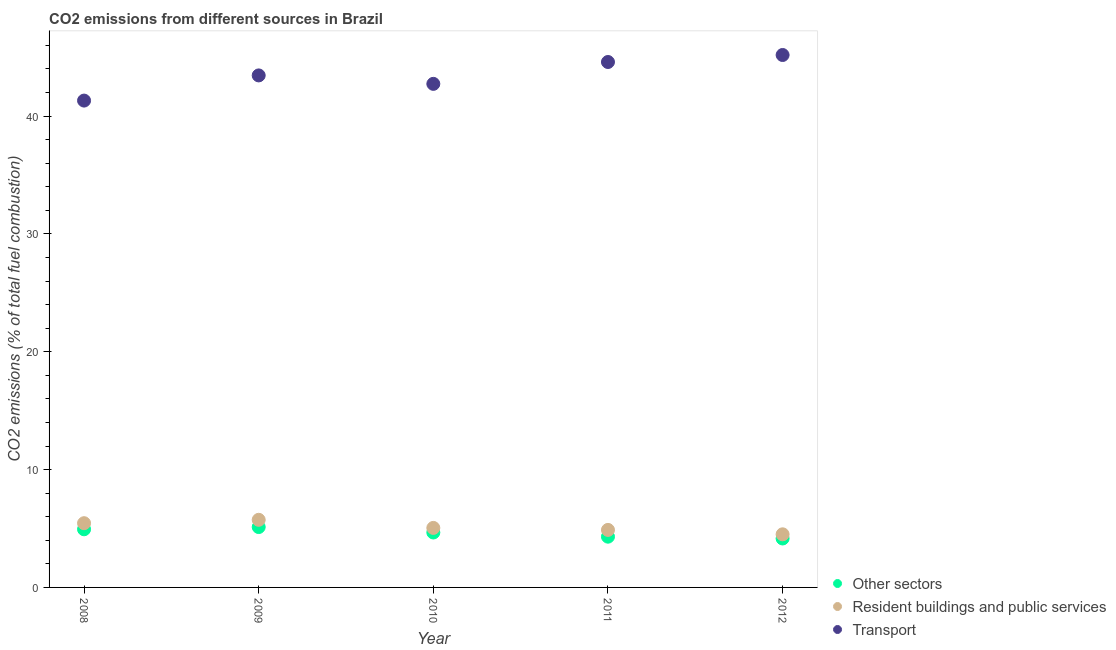How many different coloured dotlines are there?
Your response must be concise. 3. What is the percentage of co2 emissions from resident buildings and public services in 2010?
Offer a terse response. 5.05. Across all years, what is the maximum percentage of co2 emissions from other sectors?
Your answer should be very brief. 5.12. Across all years, what is the minimum percentage of co2 emissions from other sectors?
Offer a very short reply. 4.15. In which year was the percentage of co2 emissions from resident buildings and public services maximum?
Ensure brevity in your answer.  2009. What is the total percentage of co2 emissions from other sectors in the graph?
Provide a short and direct response. 23.18. What is the difference between the percentage of co2 emissions from other sectors in 2008 and that in 2009?
Offer a very short reply. -0.19. What is the difference between the percentage of co2 emissions from resident buildings and public services in 2011 and the percentage of co2 emissions from transport in 2010?
Provide a succinct answer. -37.85. What is the average percentage of co2 emissions from resident buildings and public services per year?
Provide a short and direct response. 5.12. In the year 2012, what is the difference between the percentage of co2 emissions from transport and percentage of co2 emissions from other sectors?
Your answer should be compact. 41.03. What is the ratio of the percentage of co2 emissions from resident buildings and public services in 2009 to that in 2012?
Your answer should be compact. 1.27. Is the percentage of co2 emissions from transport in 2010 less than that in 2012?
Make the answer very short. Yes. What is the difference between the highest and the second highest percentage of co2 emissions from transport?
Offer a very short reply. 0.59. What is the difference between the highest and the lowest percentage of co2 emissions from transport?
Keep it short and to the point. 3.87. Is the percentage of co2 emissions from other sectors strictly greater than the percentage of co2 emissions from transport over the years?
Give a very brief answer. No. What is the difference between two consecutive major ticks on the Y-axis?
Provide a short and direct response. 10. How many legend labels are there?
Your answer should be compact. 3. How are the legend labels stacked?
Make the answer very short. Vertical. What is the title of the graph?
Keep it short and to the point. CO2 emissions from different sources in Brazil. Does "Nuclear sources" appear as one of the legend labels in the graph?
Provide a short and direct response. No. What is the label or title of the X-axis?
Your answer should be compact. Year. What is the label or title of the Y-axis?
Offer a very short reply. CO2 emissions (% of total fuel combustion). What is the CO2 emissions (% of total fuel combustion) of Other sectors in 2008?
Your answer should be very brief. 4.93. What is the CO2 emissions (% of total fuel combustion) in Resident buildings and public services in 2008?
Your answer should be compact. 5.45. What is the CO2 emissions (% of total fuel combustion) in Transport in 2008?
Give a very brief answer. 41.31. What is the CO2 emissions (% of total fuel combustion) in Other sectors in 2009?
Ensure brevity in your answer.  5.12. What is the CO2 emissions (% of total fuel combustion) in Resident buildings and public services in 2009?
Your answer should be very brief. 5.74. What is the CO2 emissions (% of total fuel combustion) in Transport in 2009?
Provide a succinct answer. 43.45. What is the CO2 emissions (% of total fuel combustion) in Other sectors in 2010?
Ensure brevity in your answer.  4.66. What is the CO2 emissions (% of total fuel combustion) of Resident buildings and public services in 2010?
Your answer should be compact. 5.05. What is the CO2 emissions (% of total fuel combustion) of Transport in 2010?
Offer a terse response. 42.73. What is the CO2 emissions (% of total fuel combustion) in Other sectors in 2011?
Offer a very short reply. 4.31. What is the CO2 emissions (% of total fuel combustion) in Resident buildings and public services in 2011?
Your response must be concise. 4.88. What is the CO2 emissions (% of total fuel combustion) in Transport in 2011?
Ensure brevity in your answer.  44.58. What is the CO2 emissions (% of total fuel combustion) of Other sectors in 2012?
Ensure brevity in your answer.  4.15. What is the CO2 emissions (% of total fuel combustion) of Resident buildings and public services in 2012?
Provide a succinct answer. 4.51. What is the CO2 emissions (% of total fuel combustion) in Transport in 2012?
Ensure brevity in your answer.  45.18. Across all years, what is the maximum CO2 emissions (% of total fuel combustion) in Other sectors?
Provide a short and direct response. 5.12. Across all years, what is the maximum CO2 emissions (% of total fuel combustion) in Resident buildings and public services?
Ensure brevity in your answer.  5.74. Across all years, what is the maximum CO2 emissions (% of total fuel combustion) in Transport?
Provide a succinct answer. 45.18. Across all years, what is the minimum CO2 emissions (% of total fuel combustion) in Other sectors?
Provide a succinct answer. 4.15. Across all years, what is the minimum CO2 emissions (% of total fuel combustion) of Resident buildings and public services?
Offer a very short reply. 4.51. Across all years, what is the minimum CO2 emissions (% of total fuel combustion) in Transport?
Give a very brief answer. 41.31. What is the total CO2 emissions (% of total fuel combustion) of Other sectors in the graph?
Provide a succinct answer. 23.18. What is the total CO2 emissions (% of total fuel combustion) in Resident buildings and public services in the graph?
Keep it short and to the point. 25.62. What is the total CO2 emissions (% of total fuel combustion) of Transport in the graph?
Your answer should be very brief. 217.24. What is the difference between the CO2 emissions (% of total fuel combustion) of Other sectors in 2008 and that in 2009?
Your answer should be very brief. -0.19. What is the difference between the CO2 emissions (% of total fuel combustion) in Resident buildings and public services in 2008 and that in 2009?
Your answer should be very brief. -0.29. What is the difference between the CO2 emissions (% of total fuel combustion) in Transport in 2008 and that in 2009?
Keep it short and to the point. -2.14. What is the difference between the CO2 emissions (% of total fuel combustion) in Other sectors in 2008 and that in 2010?
Your answer should be very brief. 0.27. What is the difference between the CO2 emissions (% of total fuel combustion) of Resident buildings and public services in 2008 and that in 2010?
Provide a succinct answer. 0.4. What is the difference between the CO2 emissions (% of total fuel combustion) in Transport in 2008 and that in 2010?
Ensure brevity in your answer.  -1.42. What is the difference between the CO2 emissions (% of total fuel combustion) in Other sectors in 2008 and that in 2011?
Your response must be concise. 0.63. What is the difference between the CO2 emissions (% of total fuel combustion) of Resident buildings and public services in 2008 and that in 2011?
Provide a succinct answer. 0.57. What is the difference between the CO2 emissions (% of total fuel combustion) in Transport in 2008 and that in 2011?
Provide a succinct answer. -3.27. What is the difference between the CO2 emissions (% of total fuel combustion) of Other sectors in 2008 and that in 2012?
Keep it short and to the point. 0.78. What is the difference between the CO2 emissions (% of total fuel combustion) of Resident buildings and public services in 2008 and that in 2012?
Your response must be concise. 0.94. What is the difference between the CO2 emissions (% of total fuel combustion) in Transport in 2008 and that in 2012?
Keep it short and to the point. -3.87. What is the difference between the CO2 emissions (% of total fuel combustion) of Other sectors in 2009 and that in 2010?
Your answer should be very brief. 0.46. What is the difference between the CO2 emissions (% of total fuel combustion) in Resident buildings and public services in 2009 and that in 2010?
Ensure brevity in your answer.  0.69. What is the difference between the CO2 emissions (% of total fuel combustion) of Transport in 2009 and that in 2010?
Ensure brevity in your answer.  0.72. What is the difference between the CO2 emissions (% of total fuel combustion) of Other sectors in 2009 and that in 2011?
Provide a succinct answer. 0.82. What is the difference between the CO2 emissions (% of total fuel combustion) in Resident buildings and public services in 2009 and that in 2011?
Your answer should be compact. 0.86. What is the difference between the CO2 emissions (% of total fuel combustion) of Transport in 2009 and that in 2011?
Ensure brevity in your answer.  -1.14. What is the difference between the CO2 emissions (% of total fuel combustion) of Other sectors in 2009 and that in 2012?
Give a very brief answer. 0.97. What is the difference between the CO2 emissions (% of total fuel combustion) of Resident buildings and public services in 2009 and that in 2012?
Ensure brevity in your answer.  1.23. What is the difference between the CO2 emissions (% of total fuel combustion) of Transport in 2009 and that in 2012?
Keep it short and to the point. -1.73. What is the difference between the CO2 emissions (% of total fuel combustion) in Other sectors in 2010 and that in 2011?
Your answer should be very brief. 0.35. What is the difference between the CO2 emissions (% of total fuel combustion) in Resident buildings and public services in 2010 and that in 2011?
Your answer should be very brief. 0.17. What is the difference between the CO2 emissions (% of total fuel combustion) in Transport in 2010 and that in 2011?
Give a very brief answer. -1.85. What is the difference between the CO2 emissions (% of total fuel combustion) in Other sectors in 2010 and that in 2012?
Offer a terse response. 0.51. What is the difference between the CO2 emissions (% of total fuel combustion) of Resident buildings and public services in 2010 and that in 2012?
Your answer should be very brief. 0.54. What is the difference between the CO2 emissions (% of total fuel combustion) in Transport in 2010 and that in 2012?
Provide a succinct answer. -2.45. What is the difference between the CO2 emissions (% of total fuel combustion) of Other sectors in 2011 and that in 2012?
Offer a terse response. 0.15. What is the difference between the CO2 emissions (% of total fuel combustion) in Resident buildings and public services in 2011 and that in 2012?
Your answer should be compact. 0.37. What is the difference between the CO2 emissions (% of total fuel combustion) of Transport in 2011 and that in 2012?
Offer a terse response. -0.59. What is the difference between the CO2 emissions (% of total fuel combustion) in Other sectors in 2008 and the CO2 emissions (% of total fuel combustion) in Resident buildings and public services in 2009?
Offer a very short reply. -0.8. What is the difference between the CO2 emissions (% of total fuel combustion) in Other sectors in 2008 and the CO2 emissions (% of total fuel combustion) in Transport in 2009?
Your answer should be compact. -38.51. What is the difference between the CO2 emissions (% of total fuel combustion) of Resident buildings and public services in 2008 and the CO2 emissions (% of total fuel combustion) of Transport in 2009?
Give a very brief answer. -38. What is the difference between the CO2 emissions (% of total fuel combustion) of Other sectors in 2008 and the CO2 emissions (% of total fuel combustion) of Resident buildings and public services in 2010?
Provide a succinct answer. -0.12. What is the difference between the CO2 emissions (% of total fuel combustion) of Other sectors in 2008 and the CO2 emissions (% of total fuel combustion) of Transport in 2010?
Your answer should be compact. -37.8. What is the difference between the CO2 emissions (% of total fuel combustion) of Resident buildings and public services in 2008 and the CO2 emissions (% of total fuel combustion) of Transport in 2010?
Provide a succinct answer. -37.28. What is the difference between the CO2 emissions (% of total fuel combustion) of Other sectors in 2008 and the CO2 emissions (% of total fuel combustion) of Resident buildings and public services in 2011?
Provide a short and direct response. 0.05. What is the difference between the CO2 emissions (% of total fuel combustion) of Other sectors in 2008 and the CO2 emissions (% of total fuel combustion) of Transport in 2011?
Ensure brevity in your answer.  -39.65. What is the difference between the CO2 emissions (% of total fuel combustion) in Resident buildings and public services in 2008 and the CO2 emissions (% of total fuel combustion) in Transport in 2011?
Offer a terse response. -39.13. What is the difference between the CO2 emissions (% of total fuel combustion) in Other sectors in 2008 and the CO2 emissions (% of total fuel combustion) in Resident buildings and public services in 2012?
Your answer should be very brief. 0.43. What is the difference between the CO2 emissions (% of total fuel combustion) in Other sectors in 2008 and the CO2 emissions (% of total fuel combustion) in Transport in 2012?
Your answer should be compact. -40.24. What is the difference between the CO2 emissions (% of total fuel combustion) of Resident buildings and public services in 2008 and the CO2 emissions (% of total fuel combustion) of Transport in 2012?
Provide a succinct answer. -39.73. What is the difference between the CO2 emissions (% of total fuel combustion) of Other sectors in 2009 and the CO2 emissions (% of total fuel combustion) of Resident buildings and public services in 2010?
Make the answer very short. 0.07. What is the difference between the CO2 emissions (% of total fuel combustion) in Other sectors in 2009 and the CO2 emissions (% of total fuel combustion) in Transport in 2010?
Your answer should be very brief. -37.61. What is the difference between the CO2 emissions (% of total fuel combustion) in Resident buildings and public services in 2009 and the CO2 emissions (% of total fuel combustion) in Transport in 2010?
Keep it short and to the point. -36.99. What is the difference between the CO2 emissions (% of total fuel combustion) of Other sectors in 2009 and the CO2 emissions (% of total fuel combustion) of Resident buildings and public services in 2011?
Your answer should be very brief. 0.24. What is the difference between the CO2 emissions (% of total fuel combustion) of Other sectors in 2009 and the CO2 emissions (% of total fuel combustion) of Transport in 2011?
Make the answer very short. -39.46. What is the difference between the CO2 emissions (% of total fuel combustion) in Resident buildings and public services in 2009 and the CO2 emissions (% of total fuel combustion) in Transport in 2011?
Ensure brevity in your answer.  -38.85. What is the difference between the CO2 emissions (% of total fuel combustion) in Other sectors in 2009 and the CO2 emissions (% of total fuel combustion) in Resident buildings and public services in 2012?
Offer a terse response. 0.62. What is the difference between the CO2 emissions (% of total fuel combustion) in Other sectors in 2009 and the CO2 emissions (% of total fuel combustion) in Transport in 2012?
Keep it short and to the point. -40.06. What is the difference between the CO2 emissions (% of total fuel combustion) in Resident buildings and public services in 2009 and the CO2 emissions (% of total fuel combustion) in Transport in 2012?
Keep it short and to the point. -39.44. What is the difference between the CO2 emissions (% of total fuel combustion) of Other sectors in 2010 and the CO2 emissions (% of total fuel combustion) of Resident buildings and public services in 2011?
Your response must be concise. -0.22. What is the difference between the CO2 emissions (% of total fuel combustion) in Other sectors in 2010 and the CO2 emissions (% of total fuel combustion) in Transport in 2011?
Provide a short and direct response. -39.92. What is the difference between the CO2 emissions (% of total fuel combustion) in Resident buildings and public services in 2010 and the CO2 emissions (% of total fuel combustion) in Transport in 2011?
Your response must be concise. -39.53. What is the difference between the CO2 emissions (% of total fuel combustion) of Other sectors in 2010 and the CO2 emissions (% of total fuel combustion) of Resident buildings and public services in 2012?
Keep it short and to the point. 0.15. What is the difference between the CO2 emissions (% of total fuel combustion) in Other sectors in 2010 and the CO2 emissions (% of total fuel combustion) in Transport in 2012?
Make the answer very short. -40.52. What is the difference between the CO2 emissions (% of total fuel combustion) of Resident buildings and public services in 2010 and the CO2 emissions (% of total fuel combustion) of Transport in 2012?
Offer a terse response. -40.13. What is the difference between the CO2 emissions (% of total fuel combustion) in Other sectors in 2011 and the CO2 emissions (% of total fuel combustion) in Resident buildings and public services in 2012?
Keep it short and to the point. -0.2. What is the difference between the CO2 emissions (% of total fuel combustion) of Other sectors in 2011 and the CO2 emissions (% of total fuel combustion) of Transport in 2012?
Give a very brief answer. -40.87. What is the difference between the CO2 emissions (% of total fuel combustion) of Resident buildings and public services in 2011 and the CO2 emissions (% of total fuel combustion) of Transport in 2012?
Offer a very short reply. -40.3. What is the average CO2 emissions (% of total fuel combustion) of Other sectors per year?
Keep it short and to the point. 4.64. What is the average CO2 emissions (% of total fuel combustion) in Resident buildings and public services per year?
Keep it short and to the point. 5.12. What is the average CO2 emissions (% of total fuel combustion) in Transport per year?
Your answer should be very brief. 43.45. In the year 2008, what is the difference between the CO2 emissions (% of total fuel combustion) of Other sectors and CO2 emissions (% of total fuel combustion) of Resident buildings and public services?
Offer a very short reply. -0.52. In the year 2008, what is the difference between the CO2 emissions (% of total fuel combustion) in Other sectors and CO2 emissions (% of total fuel combustion) in Transport?
Offer a very short reply. -36.38. In the year 2008, what is the difference between the CO2 emissions (% of total fuel combustion) in Resident buildings and public services and CO2 emissions (% of total fuel combustion) in Transport?
Keep it short and to the point. -35.86. In the year 2009, what is the difference between the CO2 emissions (% of total fuel combustion) of Other sectors and CO2 emissions (% of total fuel combustion) of Resident buildings and public services?
Make the answer very short. -0.61. In the year 2009, what is the difference between the CO2 emissions (% of total fuel combustion) in Other sectors and CO2 emissions (% of total fuel combustion) in Transport?
Give a very brief answer. -38.32. In the year 2009, what is the difference between the CO2 emissions (% of total fuel combustion) of Resident buildings and public services and CO2 emissions (% of total fuel combustion) of Transport?
Provide a short and direct response. -37.71. In the year 2010, what is the difference between the CO2 emissions (% of total fuel combustion) in Other sectors and CO2 emissions (% of total fuel combustion) in Resident buildings and public services?
Offer a very short reply. -0.39. In the year 2010, what is the difference between the CO2 emissions (% of total fuel combustion) in Other sectors and CO2 emissions (% of total fuel combustion) in Transport?
Make the answer very short. -38.07. In the year 2010, what is the difference between the CO2 emissions (% of total fuel combustion) of Resident buildings and public services and CO2 emissions (% of total fuel combustion) of Transport?
Keep it short and to the point. -37.68. In the year 2011, what is the difference between the CO2 emissions (% of total fuel combustion) of Other sectors and CO2 emissions (% of total fuel combustion) of Resident buildings and public services?
Provide a succinct answer. -0.57. In the year 2011, what is the difference between the CO2 emissions (% of total fuel combustion) in Other sectors and CO2 emissions (% of total fuel combustion) in Transport?
Ensure brevity in your answer.  -40.28. In the year 2011, what is the difference between the CO2 emissions (% of total fuel combustion) in Resident buildings and public services and CO2 emissions (% of total fuel combustion) in Transport?
Give a very brief answer. -39.7. In the year 2012, what is the difference between the CO2 emissions (% of total fuel combustion) of Other sectors and CO2 emissions (% of total fuel combustion) of Resident buildings and public services?
Make the answer very short. -0.35. In the year 2012, what is the difference between the CO2 emissions (% of total fuel combustion) in Other sectors and CO2 emissions (% of total fuel combustion) in Transport?
Your answer should be very brief. -41.03. In the year 2012, what is the difference between the CO2 emissions (% of total fuel combustion) of Resident buildings and public services and CO2 emissions (% of total fuel combustion) of Transport?
Ensure brevity in your answer.  -40.67. What is the ratio of the CO2 emissions (% of total fuel combustion) in Other sectors in 2008 to that in 2009?
Make the answer very short. 0.96. What is the ratio of the CO2 emissions (% of total fuel combustion) of Transport in 2008 to that in 2009?
Make the answer very short. 0.95. What is the ratio of the CO2 emissions (% of total fuel combustion) in Other sectors in 2008 to that in 2010?
Provide a succinct answer. 1.06. What is the ratio of the CO2 emissions (% of total fuel combustion) in Resident buildings and public services in 2008 to that in 2010?
Offer a very short reply. 1.08. What is the ratio of the CO2 emissions (% of total fuel combustion) in Transport in 2008 to that in 2010?
Offer a very short reply. 0.97. What is the ratio of the CO2 emissions (% of total fuel combustion) of Other sectors in 2008 to that in 2011?
Give a very brief answer. 1.15. What is the ratio of the CO2 emissions (% of total fuel combustion) in Resident buildings and public services in 2008 to that in 2011?
Give a very brief answer. 1.12. What is the ratio of the CO2 emissions (% of total fuel combustion) of Transport in 2008 to that in 2011?
Provide a short and direct response. 0.93. What is the ratio of the CO2 emissions (% of total fuel combustion) of Other sectors in 2008 to that in 2012?
Keep it short and to the point. 1.19. What is the ratio of the CO2 emissions (% of total fuel combustion) in Resident buildings and public services in 2008 to that in 2012?
Your answer should be very brief. 1.21. What is the ratio of the CO2 emissions (% of total fuel combustion) of Transport in 2008 to that in 2012?
Your answer should be very brief. 0.91. What is the ratio of the CO2 emissions (% of total fuel combustion) of Other sectors in 2009 to that in 2010?
Give a very brief answer. 1.1. What is the ratio of the CO2 emissions (% of total fuel combustion) in Resident buildings and public services in 2009 to that in 2010?
Your response must be concise. 1.14. What is the ratio of the CO2 emissions (% of total fuel combustion) of Transport in 2009 to that in 2010?
Offer a terse response. 1.02. What is the ratio of the CO2 emissions (% of total fuel combustion) in Other sectors in 2009 to that in 2011?
Keep it short and to the point. 1.19. What is the ratio of the CO2 emissions (% of total fuel combustion) of Resident buildings and public services in 2009 to that in 2011?
Offer a terse response. 1.18. What is the ratio of the CO2 emissions (% of total fuel combustion) in Transport in 2009 to that in 2011?
Ensure brevity in your answer.  0.97. What is the ratio of the CO2 emissions (% of total fuel combustion) of Other sectors in 2009 to that in 2012?
Ensure brevity in your answer.  1.23. What is the ratio of the CO2 emissions (% of total fuel combustion) of Resident buildings and public services in 2009 to that in 2012?
Your answer should be very brief. 1.27. What is the ratio of the CO2 emissions (% of total fuel combustion) in Transport in 2009 to that in 2012?
Provide a succinct answer. 0.96. What is the ratio of the CO2 emissions (% of total fuel combustion) of Other sectors in 2010 to that in 2011?
Offer a terse response. 1.08. What is the ratio of the CO2 emissions (% of total fuel combustion) of Resident buildings and public services in 2010 to that in 2011?
Ensure brevity in your answer.  1.03. What is the ratio of the CO2 emissions (% of total fuel combustion) of Transport in 2010 to that in 2011?
Give a very brief answer. 0.96. What is the ratio of the CO2 emissions (% of total fuel combustion) of Other sectors in 2010 to that in 2012?
Your answer should be very brief. 1.12. What is the ratio of the CO2 emissions (% of total fuel combustion) of Resident buildings and public services in 2010 to that in 2012?
Offer a very short reply. 1.12. What is the ratio of the CO2 emissions (% of total fuel combustion) of Transport in 2010 to that in 2012?
Your answer should be very brief. 0.95. What is the ratio of the CO2 emissions (% of total fuel combustion) in Other sectors in 2011 to that in 2012?
Your response must be concise. 1.04. What is the ratio of the CO2 emissions (% of total fuel combustion) in Resident buildings and public services in 2011 to that in 2012?
Your response must be concise. 1.08. What is the difference between the highest and the second highest CO2 emissions (% of total fuel combustion) of Other sectors?
Provide a succinct answer. 0.19. What is the difference between the highest and the second highest CO2 emissions (% of total fuel combustion) of Resident buildings and public services?
Ensure brevity in your answer.  0.29. What is the difference between the highest and the second highest CO2 emissions (% of total fuel combustion) in Transport?
Ensure brevity in your answer.  0.59. What is the difference between the highest and the lowest CO2 emissions (% of total fuel combustion) of Other sectors?
Offer a very short reply. 0.97. What is the difference between the highest and the lowest CO2 emissions (% of total fuel combustion) in Resident buildings and public services?
Give a very brief answer. 1.23. What is the difference between the highest and the lowest CO2 emissions (% of total fuel combustion) in Transport?
Your answer should be compact. 3.87. 